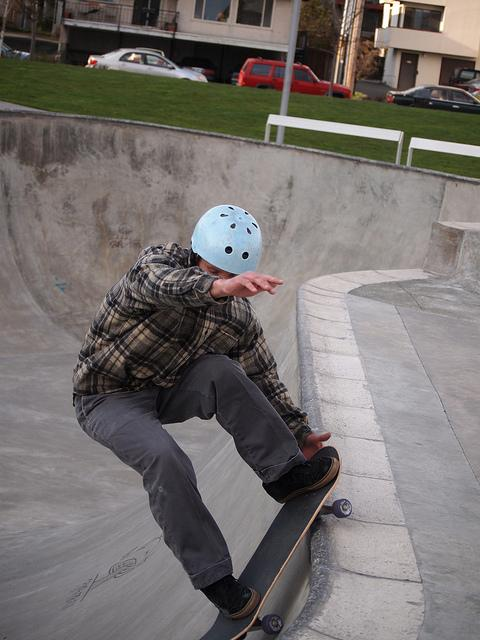Which group allegedly invented skateboards? Please explain your reasoning. surfers. People in the 60's and 70's invented skateboarding, and they were former surfers. 